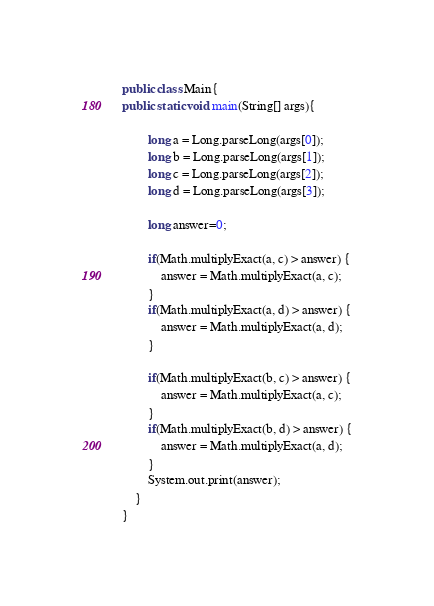<code> <loc_0><loc_0><loc_500><loc_500><_Java_>public class Main{
public static void main(String[] args){

		long a = Long.parseLong(args[0]);
		long b = Long.parseLong(args[1]);
		long c = Long.parseLong(args[2]);
		long d = Long.parseLong(args[3]);

		long answer=0;

		if(Math.multiplyExact(a, c) > answer) {
			answer = Math.multiplyExact(a, c);
		}
		if(Math.multiplyExact(a, d) > answer) {
			answer = Math.multiplyExact(a, d);
		}

		if(Math.multiplyExact(b, c) > answer) {
			answer = Math.multiplyExact(a, c);
		}
		if(Math.multiplyExact(b, d) > answer) {
			answer = Math.multiplyExact(a, d);
		}
		System.out.print(answer);
	}
}</code> 